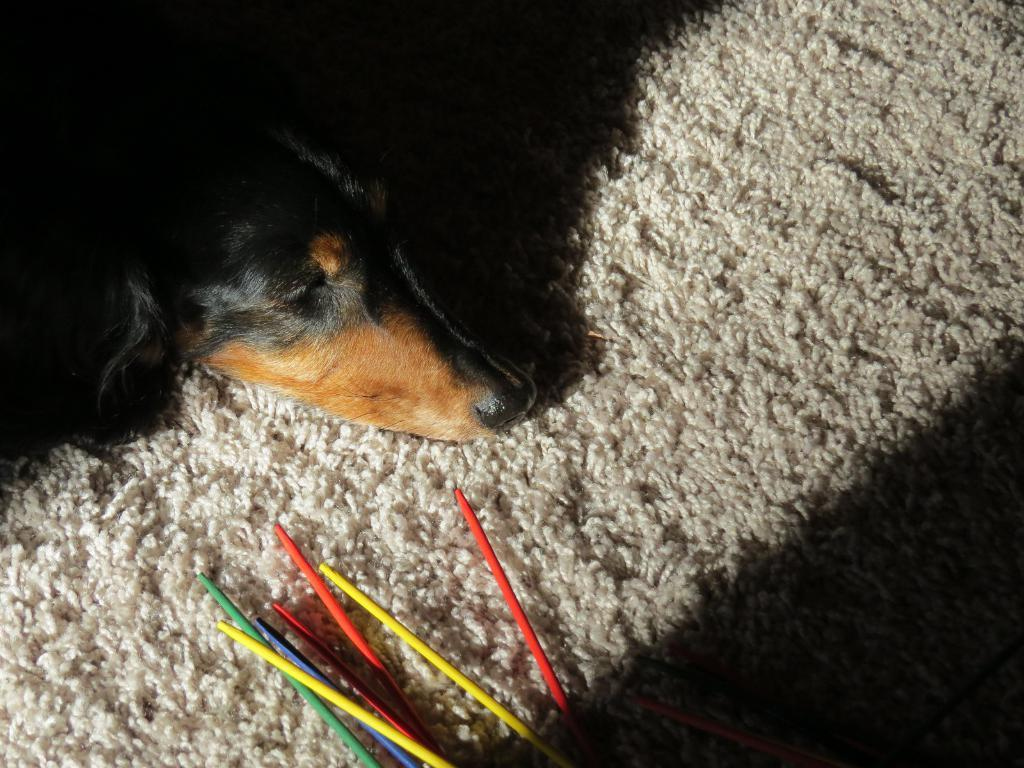What type of animal is present in the image? There is a dog in the image. What is the dog positioned on in the image? The dog is on a mat in the image. Are there any other objects or animals visible in the image? No, the only other item mentioned in the facts is the mat. What type of story is the dog telling in the image? There is no indication in the image that the dog is telling a story, as dogs do not have the ability to communicate through stories. 